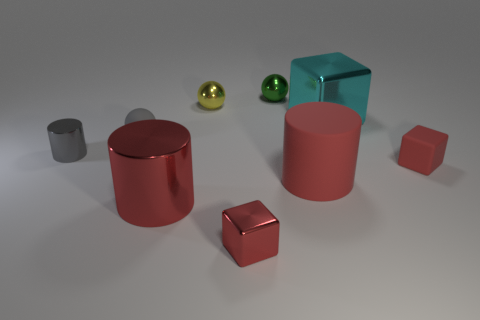Are there any big matte objects of the same color as the large metal cylinder?
Make the answer very short. Yes. Is the number of red metallic cylinders that are behind the yellow metal ball less than the number of large red matte cylinders?
Provide a succinct answer. Yes. Does the red cylinder to the right of the green object have the same size as the cyan shiny cube?
Your answer should be very brief. Yes. How many things are behind the tiny gray sphere and on the left side of the big matte cylinder?
Offer a very short reply. 2. How big is the red rubber object to the left of the cyan shiny object that is behind the rubber cylinder?
Give a very brief answer. Large. Is the number of cylinders that are on the right side of the gray shiny object less than the number of cylinders to the left of the big rubber cylinder?
Your response must be concise. No. Is the color of the big object on the left side of the tiny yellow object the same as the big cylinder right of the tiny yellow thing?
Keep it short and to the point. Yes. There is a tiny thing that is both in front of the small gray rubber thing and behind the small red rubber thing; what is it made of?
Give a very brief answer. Metal. Are any blue spheres visible?
Your response must be concise. No. There is a big thing that is made of the same material as the large cyan cube; what shape is it?
Offer a very short reply. Cylinder. 